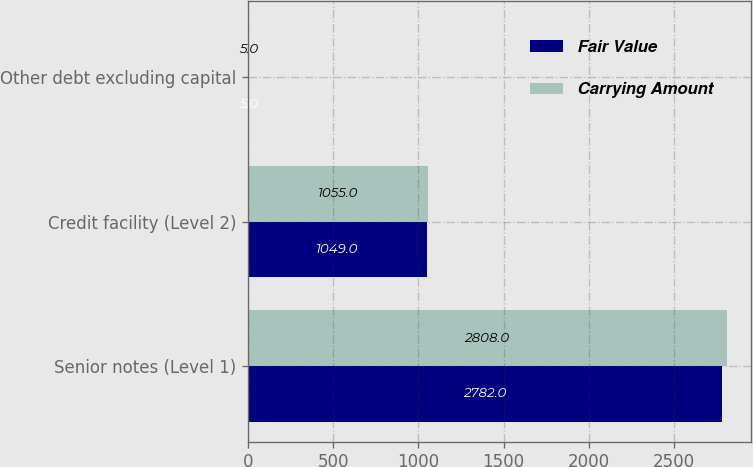Convert chart to OTSL. <chart><loc_0><loc_0><loc_500><loc_500><stacked_bar_chart><ecel><fcel>Senior notes (Level 1)<fcel>Credit facility (Level 2)<fcel>Other debt excluding capital<nl><fcel>Fair Value<fcel>2782<fcel>1049<fcel>5<nl><fcel>Carrying Amount<fcel>2808<fcel>1055<fcel>5<nl></chart> 